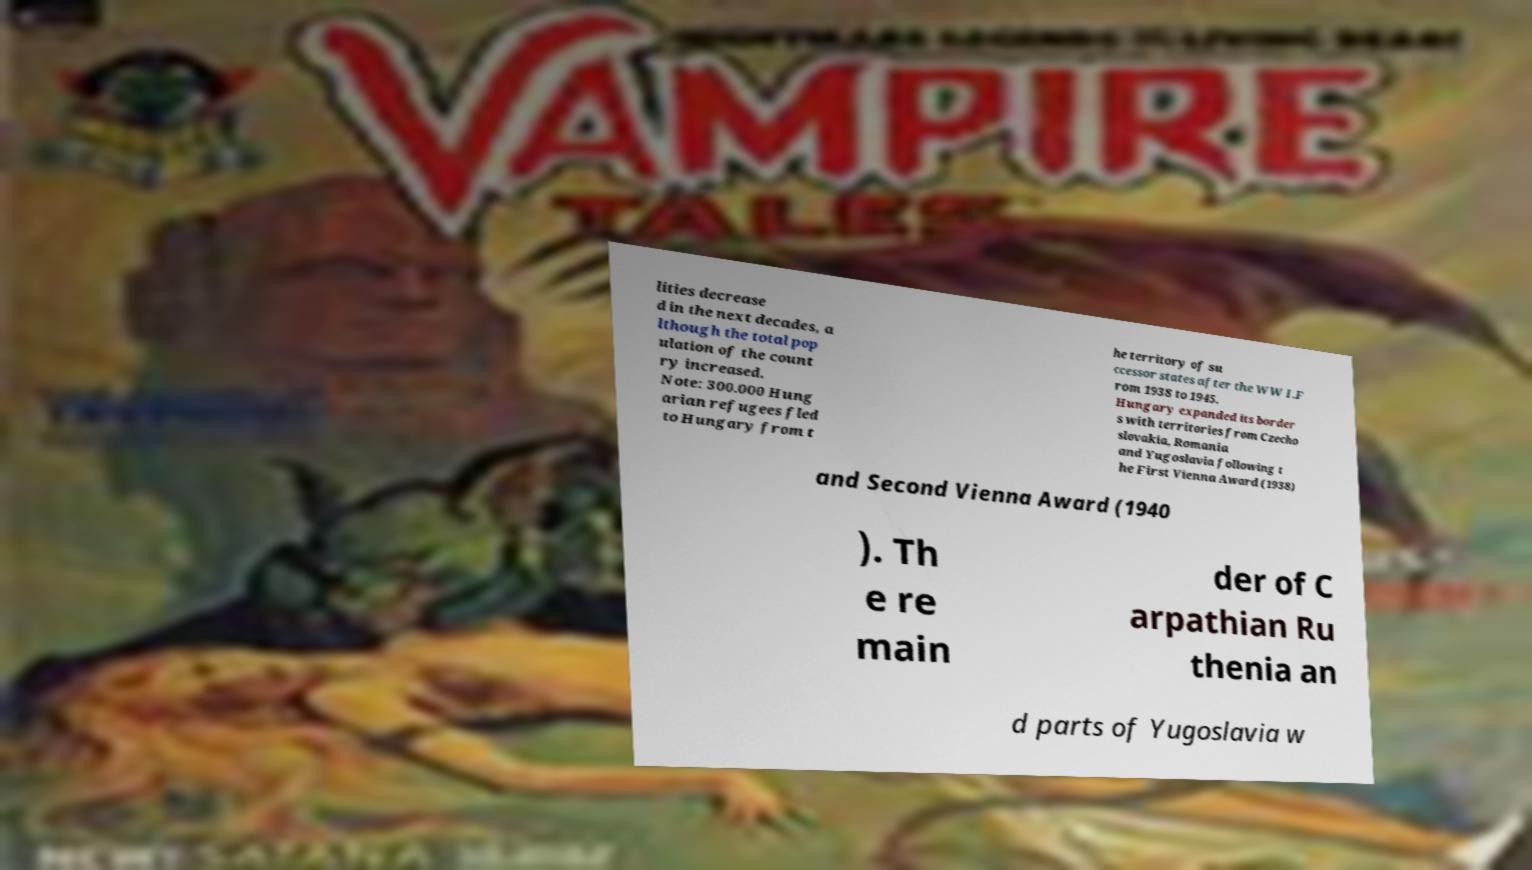Could you assist in decoding the text presented in this image and type it out clearly? lities decrease d in the next decades, a lthough the total pop ulation of the count ry increased. Note: 300.000 Hung arian refugees fled to Hungary from t he territory of su ccessor states after the WW I.F rom 1938 to 1945. Hungary expanded its border s with territories from Czecho slovakia, Romania and Yugoslavia following t he First Vienna Award (1938) and Second Vienna Award (1940 ). Th e re main der of C arpathian Ru thenia an d parts of Yugoslavia w 